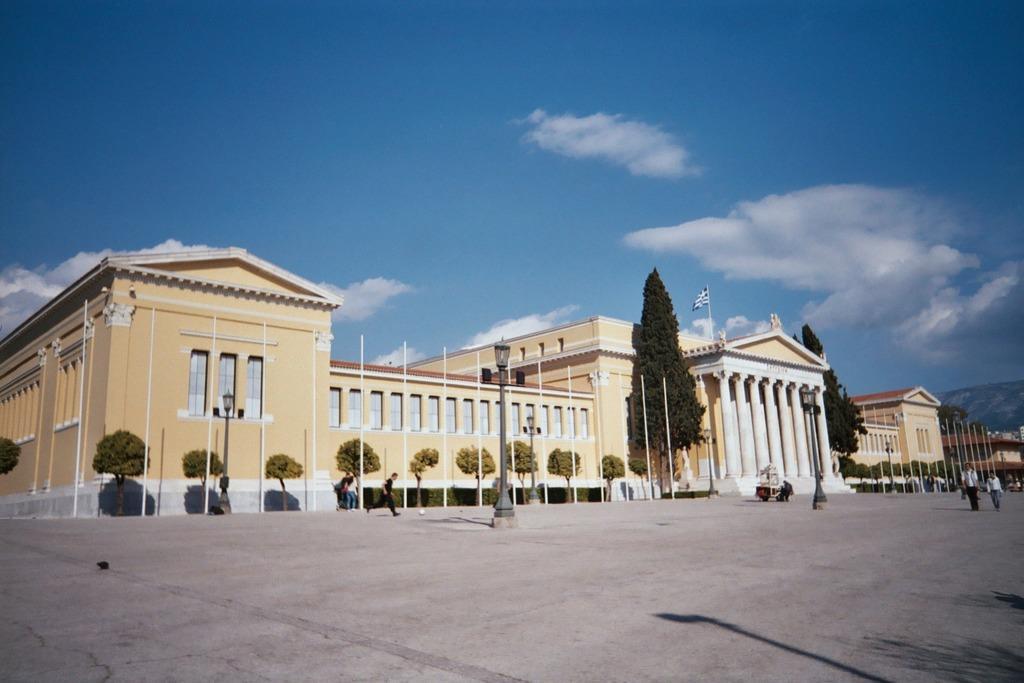Can you describe this image briefly? In this picture I can see buildings, trees and few are walking and I can see a ball, few poles, a pole light and I can see a blue cloudy sky. 